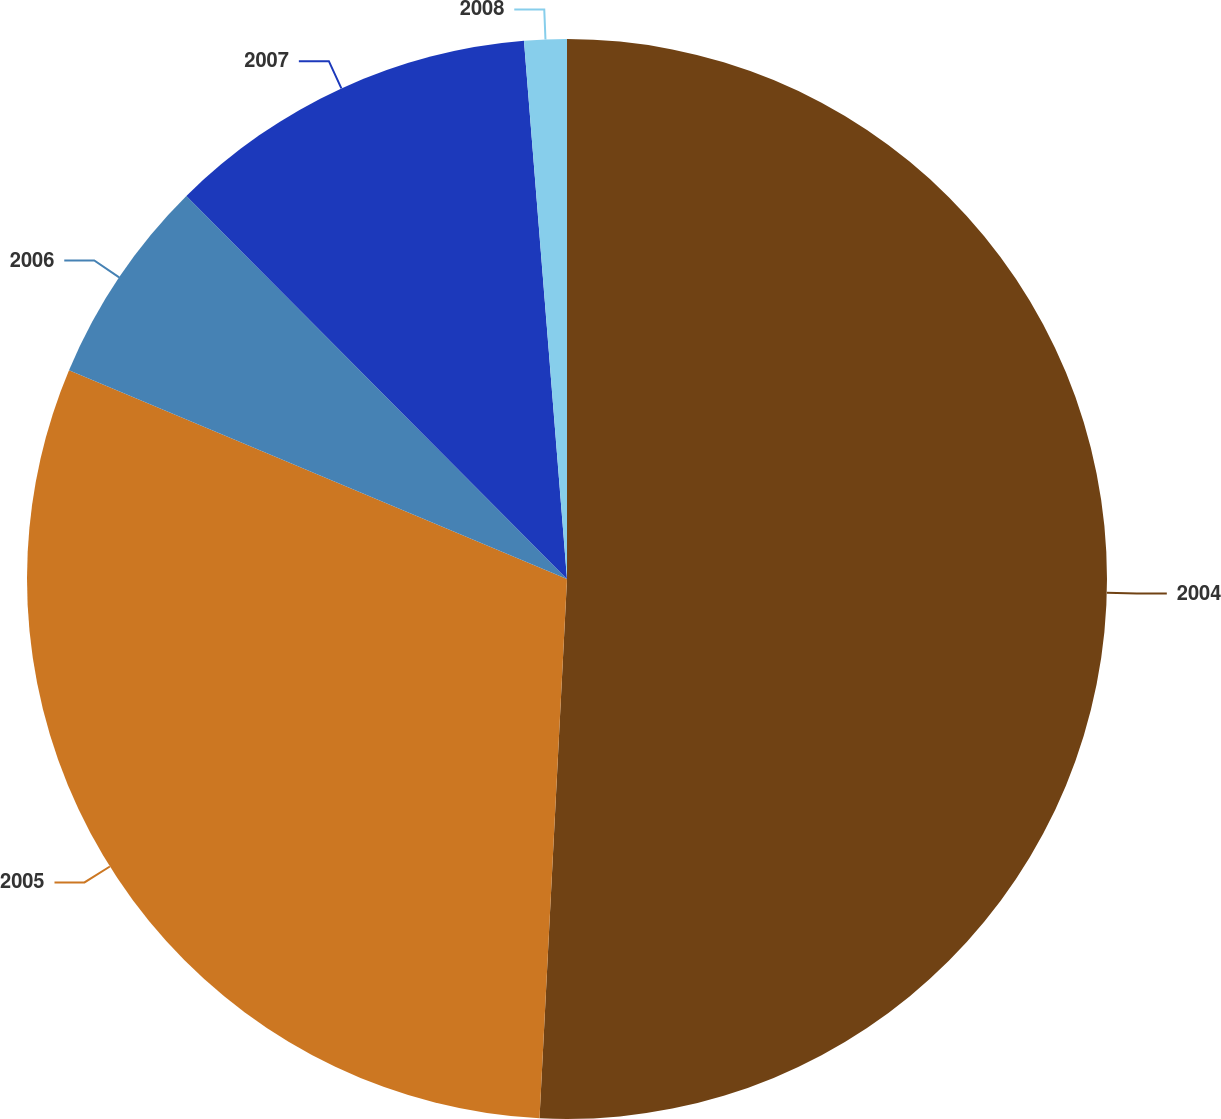<chart> <loc_0><loc_0><loc_500><loc_500><pie_chart><fcel>2004<fcel>2005<fcel>2006<fcel>2007<fcel>2008<nl><fcel>50.81%<fcel>30.51%<fcel>6.23%<fcel>11.18%<fcel>1.27%<nl></chart> 